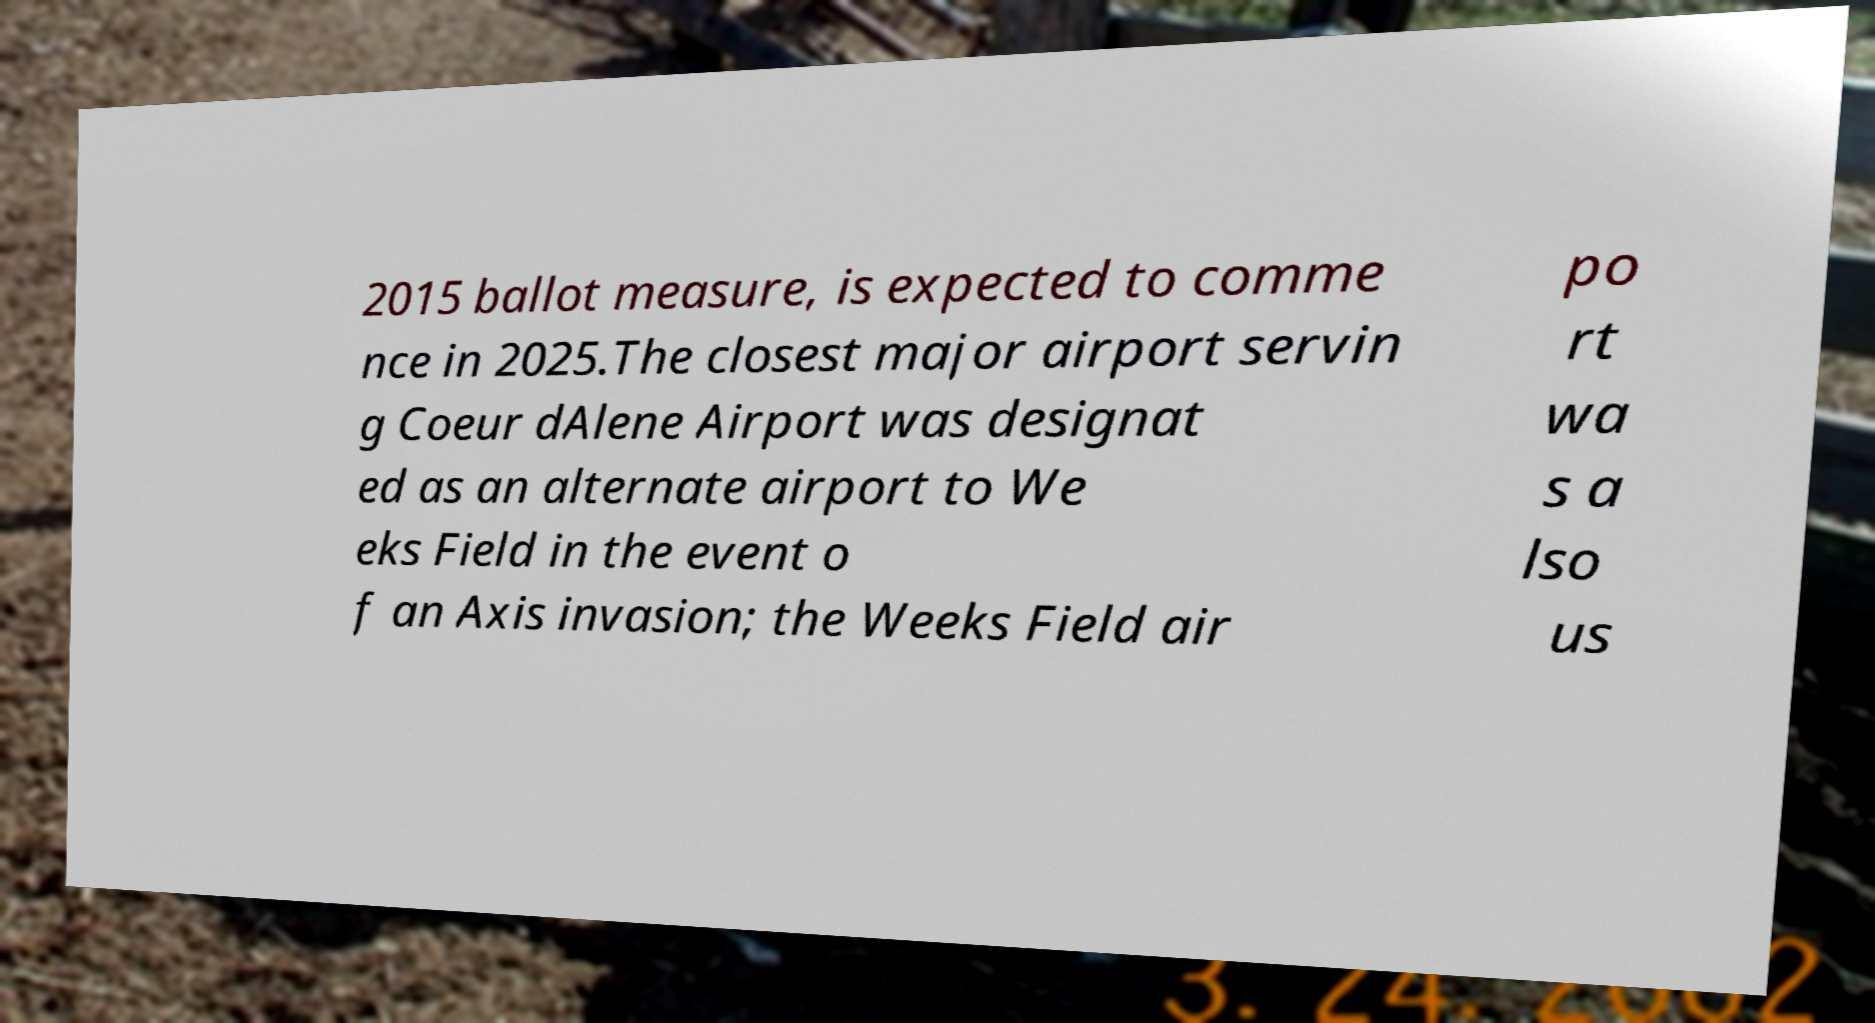Can you read and provide the text displayed in the image?This photo seems to have some interesting text. Can you extract and type it out for me? 2015 ballot measure, is expected to comme nce in 2025.The closest major airport servin g Coeur dAlene Airport was designat ed as an alternate airport to We eks Field in the event o f an Axis invasion; the Weeks Field air po rt wa s a lso us 